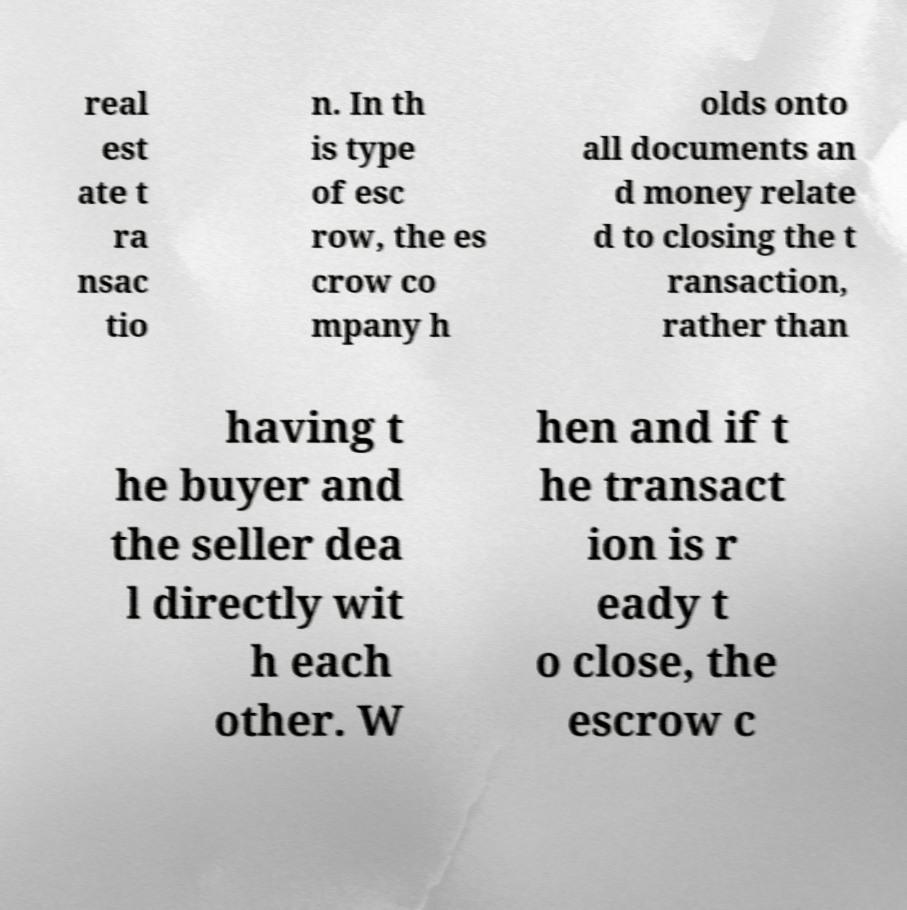Could you extract and type out the text from this image? real est ate t ra nsac tio n. In th is type of esc row, the es crow co mpany h olds onto all documents an d money relate d to closing the t ransaction, rather than having t he buyer and the seller dea l directly wit h each other. W hen and if t he transact ion is r eady t o close, the escrow c 